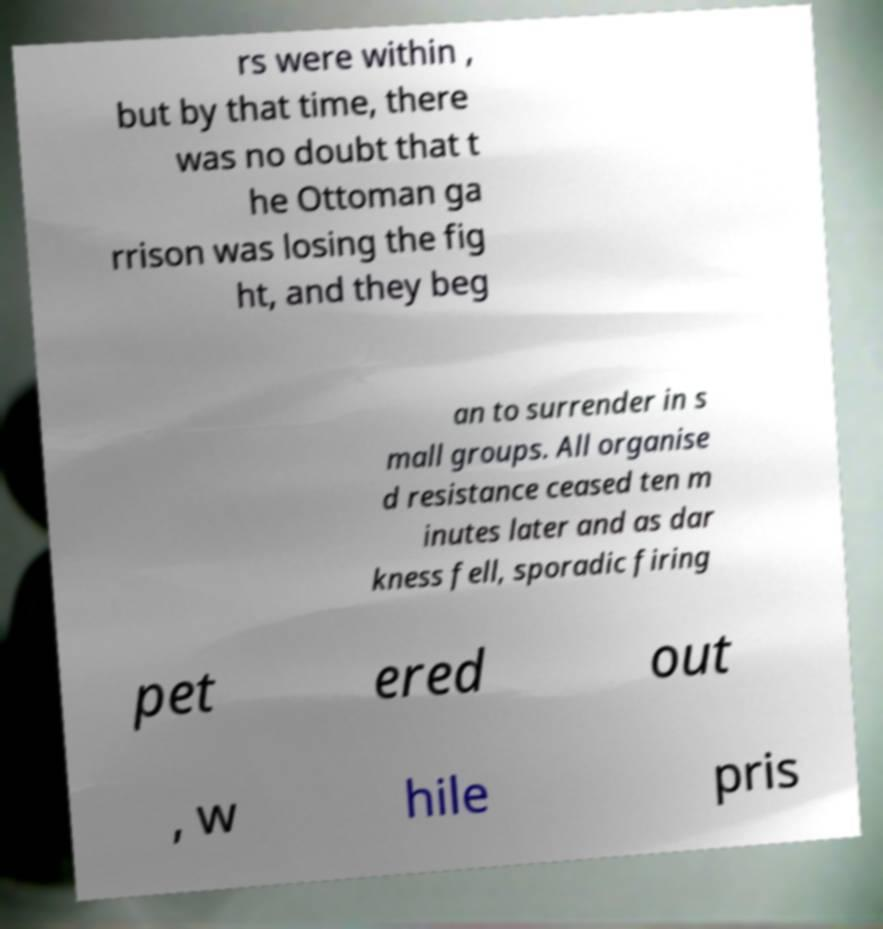What messages or text are displayed in this image? I need them in a readable, typed format. rs were within , but by that time, there was no doubt that t he Ottoman ga rrison was losing the fig ht, and they beg an to surrender in s mall groups. All organise d resistance ceased ten m inutes later and as dar kness fell, sporadic firing pet ered out , w hile pris 